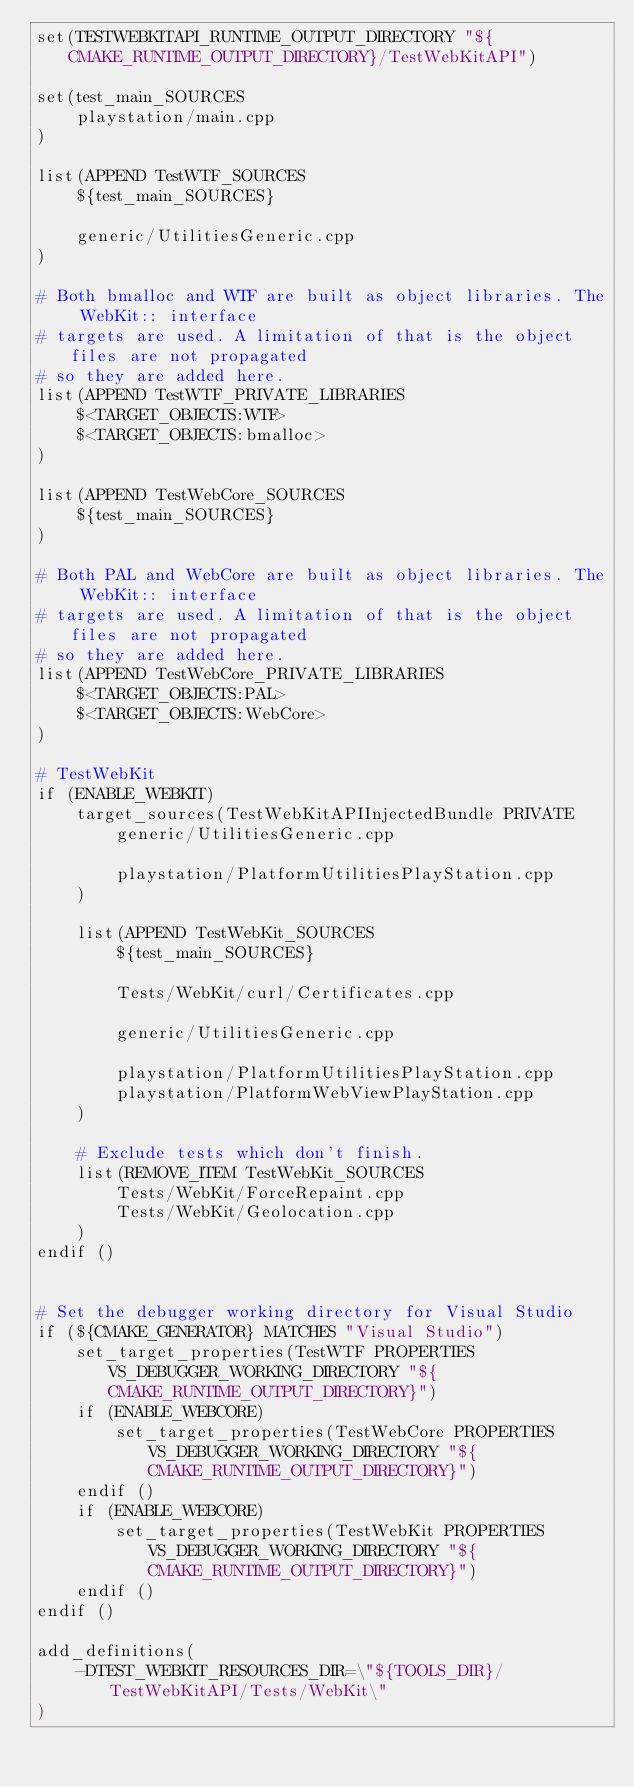<code> <loc_0><loc_0><loc_500><loc_500><_CMake_>set(TESTWEBKITAPI_RUNTIME_OUTPUT_DIRECTORY "${CMAKE_RUNTIME_OUTPUT_DIRECTORY}/TestWebKitAPI")

set(test_main_SOURCES
    playstation/main.cpp
)

list(APPEND TestWTF_SOURCES
    ${test_main_SOURCES}

    generic/UtilitiesGeneric.cpp
)

# Both bmalloc and WTF are built as object libraries. The WebKit:: interface
# targets are used. A limitation of that is the object files are not propagated
# so they are added here.
list(APPEND TestWTF_PRIVATE_LIBRARIES
    $<TARGET_OBJECTS:WTF>
    $<TARGET_OBJECTS:bmalloc>
)

list(APPEND TestWebCore_SOURCES
    ${test_main_SOURCES}
)

# Both PAL and WebCore are built as object libraries. The WebKit:: interface
# targets are used. A limitation of that is the object files are not propagated
# so they are added here.
list(APPEND TestWebCore_PRIVATE_LIBRARIES
    $<TARGET_OBJECTS:PAL>
    $<TARGET_OBJECTS:WebCore>
)

# TestWebKit
if (ENABLE_WEBKIT)
    target_sources(TestWebKitAPIInjectedBundle PRIVATE
        generic/UtilitiesGeneric.cpp

        playstation/PlatformUtilitiesPlayStation.cpp
    )

    list(APPEND TestWebKit_SOURCES
        ${test_main_SOURCES}

        Tests/WebKit/curl/Certificates.cpp

        generic/UtilitiesGeneric.cpp

        playstation/PlatformUtilitiesPlayStation.cpp
        playstation/PlatformWebViewPlayStation.cpp
    )

    # Exclude tests which don't finish.
    list(REMOVE_ITEM TestWebKit_SOURCES
        Tests/WebKit/ForceRepaint.cpp
        Tests/WebKit/Geolocation.cpp
    )
endif ()


# Set the debugger working directory for Visual Studio
if (${CMAKE_GENERATOR} MATCHES "Visual Studio")
    set_target_properties(TestWTF PROPERTIES VS_DEBUGGER_WORKING_DIRECTORY "${CMAKE_RUNTIME_OUTPUT_DIRECTORY}")
    if (ENABLE_WEBCORE)
        set_target_properties(TestWebCore PROPERTIES VS_DEBUGGER_WORKING_DIRECTORY "${CMAKE_RUNTIME_OUTPUT_DIRECTORY}")
    endif ()
    if (ENABLE_WEBCORE)
        set_target_properties(TestWebKit PROPERTIES VS_DEBUGGER_WORKING_DIRECTORY "${CMAKE_RUNTIME_OUTPUT_DIRECTORY}")
    endif ()
endif ()

add_definitions(
    -DTEST_WEBKIT_RESOURCES_DIR=\"${TOOLS_DIR}/TestWebKitAPI/Tests/WebKit\"
)
</code> 